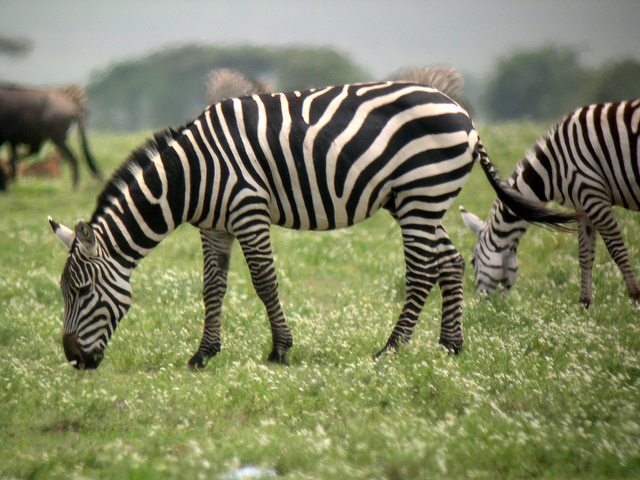What can you infer about the habitat of the zebras from this image? From the image, we can infer that the zebras' habitat includes open grasslands. The abundance of grass and the presence of other zebras suggest a savanna or plains environment, which provides ample grazing opportunities. The background shows a relatively flat terrain with distant trees, indicative of a typical African savanna where zebras are commonly found. This type of habitat supports the zebras' need for open spaces to spot predators and sufficient vegetation for feeding. How does the zebra's striped pattern help it survive in its environment? The zebra's striped pattern serves several survival functions. Primarily, it provides camouflage by creating a visual illusion that makes it harder for predators to single out an individual zebra when they are grouped together. This blending of stripes creates a confusing visual effect for predators.

Additionally, the stripes may also help in social bonding and recognition among other zebras. Each zebra has a unique stripe pattern, making it easier for them to identify family members and maintain group cohesion.

Moreover, the stripes might play a role in thermoregulation. The contrasting black and white areas could help with heat dispersion, keeping zebras cool under the harsh sun of the savanna. Stripes might also deter biting insects, as there is evidence suggesting that flies are less likely to land on striped patterns. Imagine the zebras have discovered a hidden oasis within the savanna. Describe what happens next. The discovery of a hidden oasis within the savanna sends a wave of excitement through the zebra herd. As they approach the oasis, their ears perk up and they quicken their pace, eager to reach the lush area. The oasis, teeming with fresh water and verdant vegetation, offers a welcome respite from the otherwise parched landscape.

Upon arriving, the zebras rush to the water’s edge to drink, taking deep, refreshing gulps of the cool water. The foals playfully splash in the shallow parts, while the adults graze on the abundant greenery. Birds flutter around, joining the scene, and a light breeze rustles the leaves of the surrounding trees, creating a serene and harmonious environment.

The oasis also attracts other wildlife, forming a temporary truce among the usual predators and prey. Lions, gazelles, and elephants share the space peacefully, all drawn by the rare and abundant resources the oasis provides. For a brief period, this hidden gem transforms the savanna into a sanctuary where wildlife coexist harmoniously, each taking their fill before returning to the harsher realities of their natural setting. 